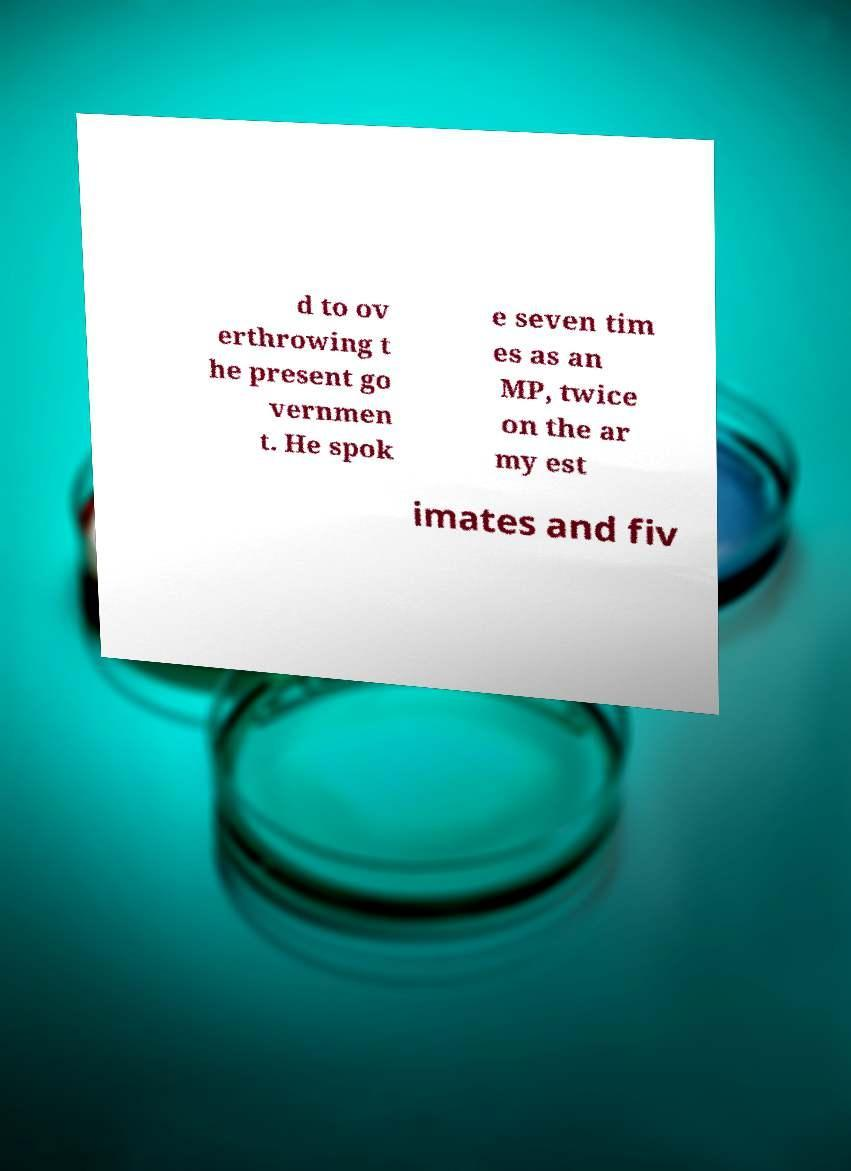What messages or text are displayed in this image? I need them in a readable, typed format. d to ov erthrowing t he present go vernmen t. He spok e seven tim es as an MP, twice on the ar my est imates and fiv 